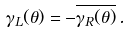Convert formula to latex. <formula><loc_0><loc_0><loc_500><loc_500>\gamma _ { L } ( \theta ) = - \overline { \gamma _ { R } ( \theta ) } \, .</formula> 